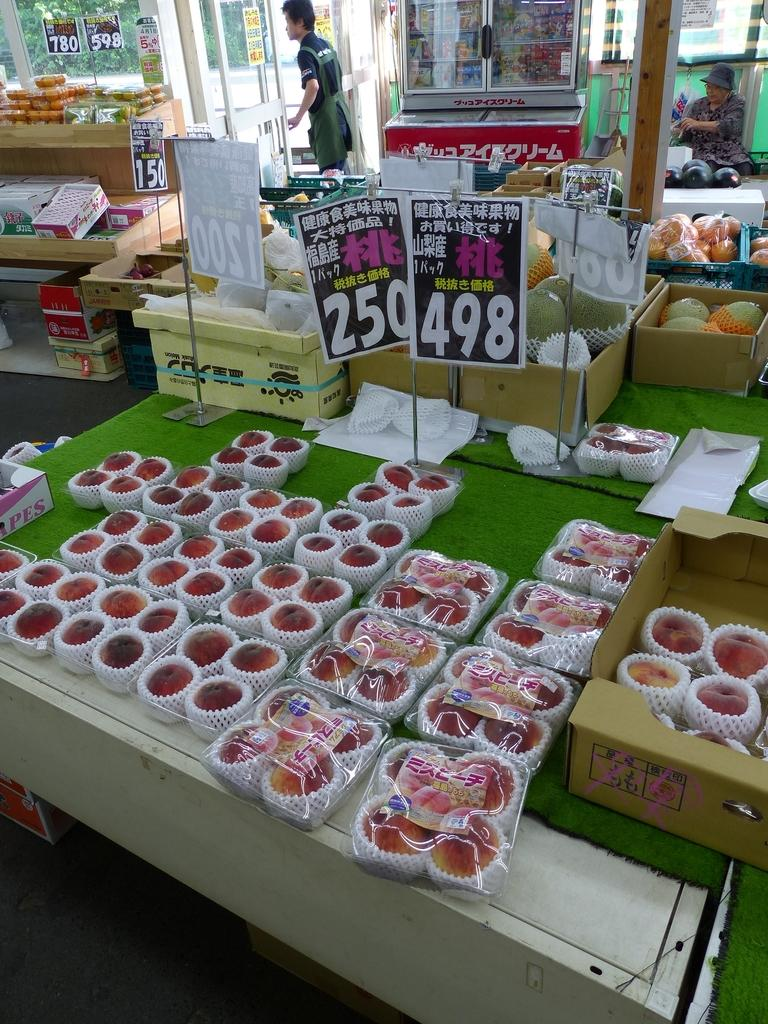<image>
Create a compact narrative representing the image presented. A display of products on a table have prices of 250 and 498. 